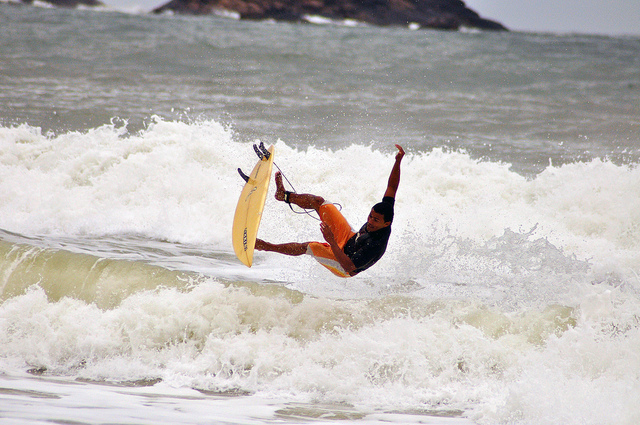How many elephants can be seen? There are no elephants visible in the image. The picture actually shows a person skillfully surfing a wave at the beach. 